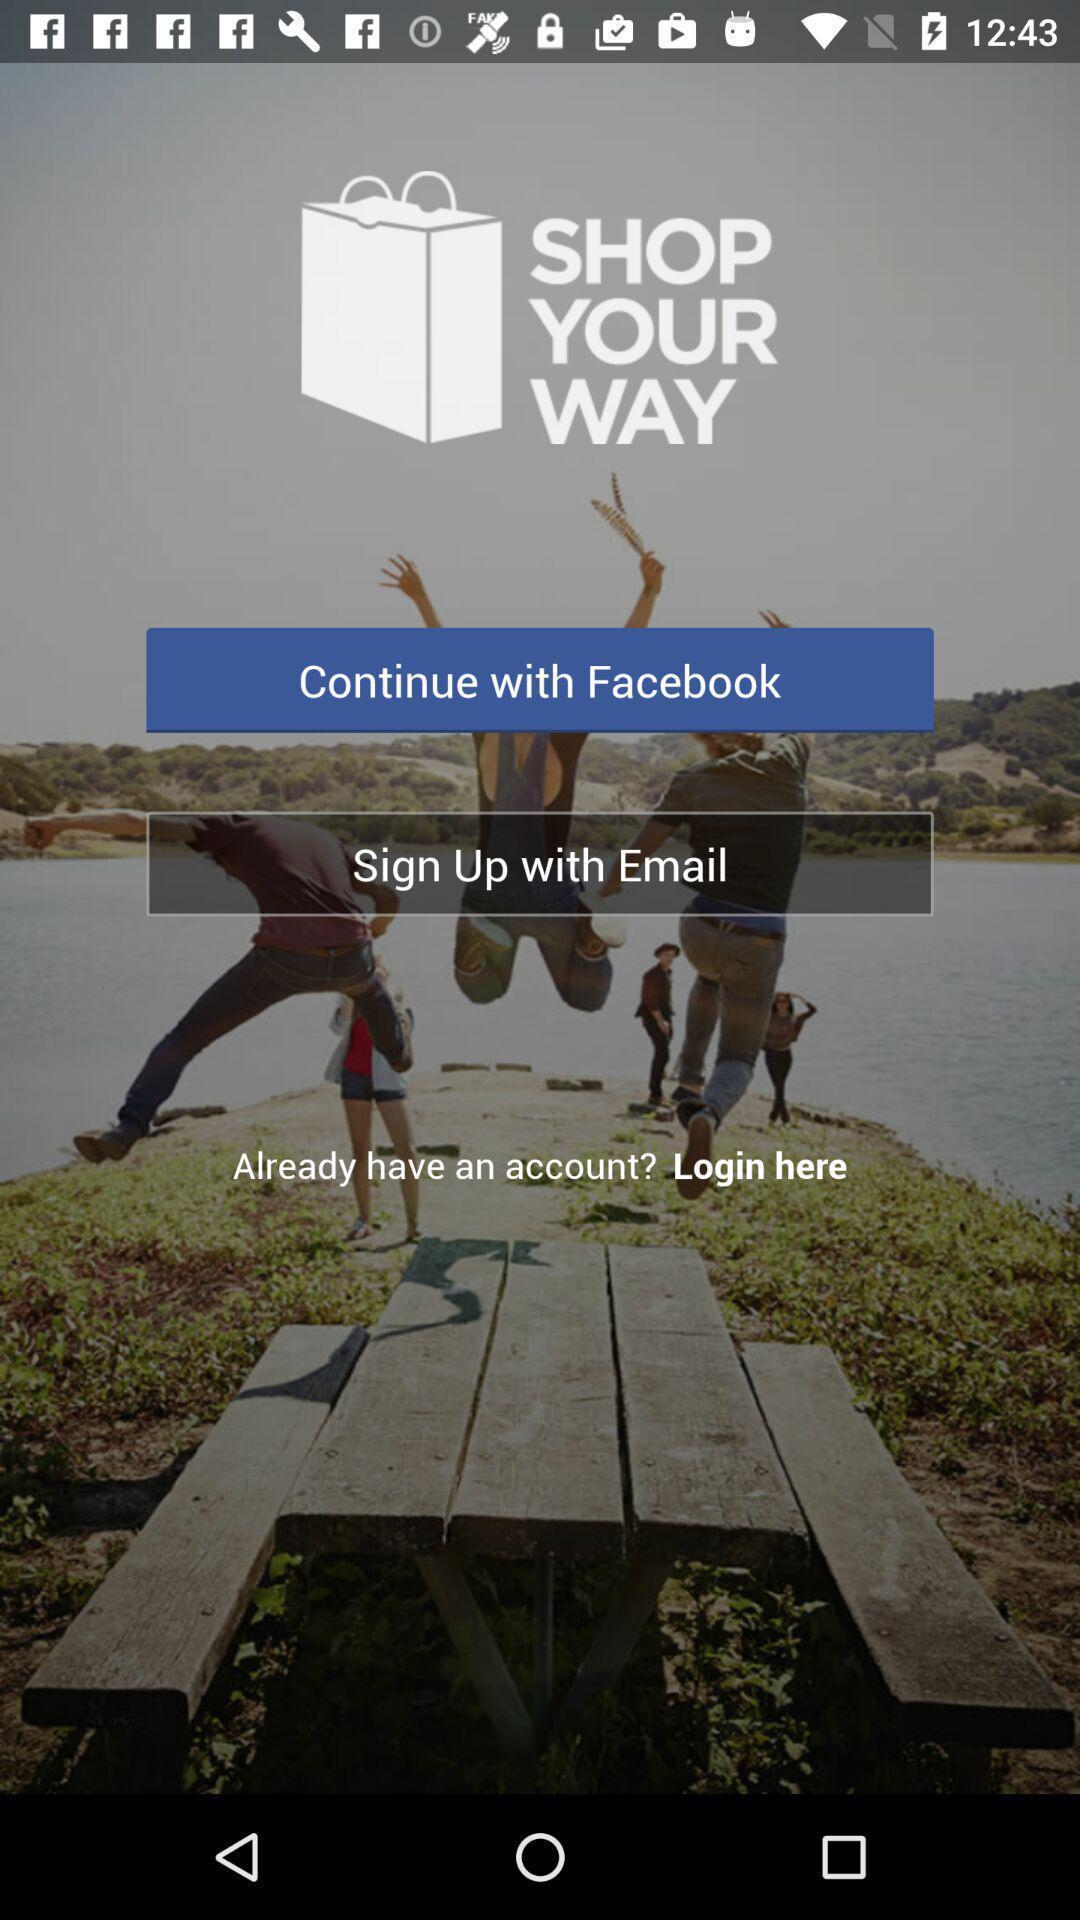Tell me what you see in this picture. Welcome page. 